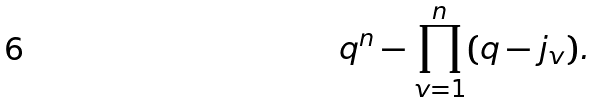<formula> <loc_0><loc_0><loc_500><loc_500>q ^ { n } - \prod _ { v = 1 } ^ { n } ( q - j _ { v } ) .</formula> 